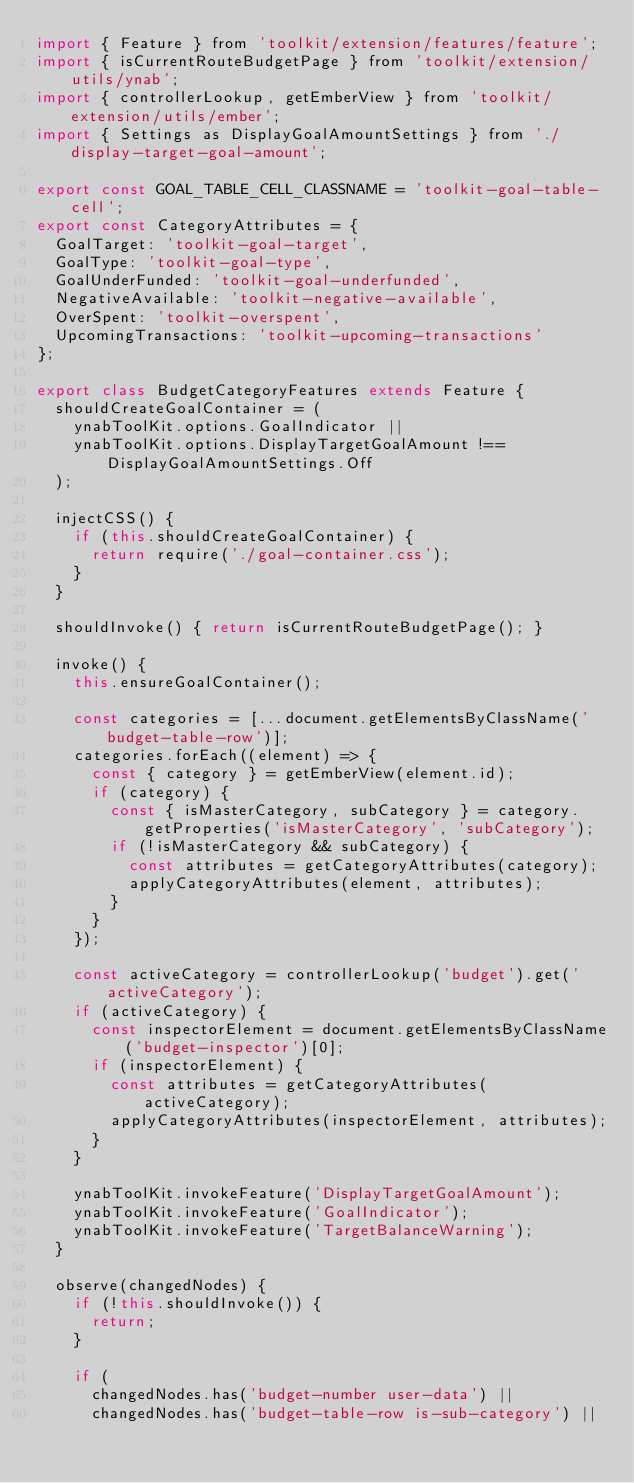<code> <loc_0><loc_0><loc_500><loc_500><_JavaScript_>import { Feature } from 'toolkit/extension/features/feature';
import { isCurrentRouteBudgetPage } from 'toolkit/extension/utils/ynab';
import { controllerLookup, getEmberView } from 'toolkit/extension/utils/ember';
import { Settings as DisplayGoalAmountSettings } from './display-target-goal-amount';

export const GOAL_TABLE_CELL_CLASSNAME = 'toolkit-goal-table-cell';
export const CategoryAttributes = {
  GoalTarget: 'toolkit-goal-target',
  GoalType: 'toolkit-goal-type',
  GoalUnderFunded: 'toolkit-goal-underfunded',
  NegativeAvailable: 'toolkit-negative-available',
  OverSpent: 'toolkit-overspent',
  UpcomingTransactions: 'toolkit-upcoming-transactions'
};

export class BudgetCategoryFeatures extends Feature {
  shouldCreateGoalContainer = (
    ynabToolKit.options.GoalIndicator ||
    ynabToolKit.options.DisplayTargetGoalAmount !== DisplayGoalAmountSettings.Off
  );

  injectCSS() {
    if (this.shouldCreateGoalContainer) {
      return require('./goal-container.css');
    }
  }

  shouldInvoke() { return isCurrentRouteBudgetPage(); }

  invoke() {
    this.ensureGoalContainer();

    const categories = [...document.getElementsByClassName('budget-table-row')];
    categories.forEach((element) => {
      const { category } = getEmberView(element.id);
      if (category) {
        const { isMasterCategory, subCategory } = category.getProperties('isMasterCategory', 'subCategory');
        if (!isMasterCategory && subCategory) {
          const attributes = getCategoryAttributes(category);
          applyCategoryAttributes(element, attributes);
        }
      }
    });

    const activeCategory = controllerLookup('budget').get('activeCategory');
    if (activeCategory) {
      const inspectorElement = document.getElementsByClassName('budget-inspector')[0];
      if (inspectorElement) {
        const attributes = getCategoryAttributes(activeCategory);
        applyCategoryAttributes(inspectorElement, attributes);
      }
    }

    ynabToolKit.invokeFeature('DisplayTargetGoalAmount');
    ynabToolKit.invokeFeature('GoalIndicator');
    ynabToolKit.invokeFeature('TargetBalanceWarning');
  }

  observe(changedNodes) {
    if (!this.shouldInvoke()) {
      return;
    }

    if (
      changedNodes.has('budget-number user-data') ||
      changedNodes.has('budget-table-row is-sub-category') ||</code> 